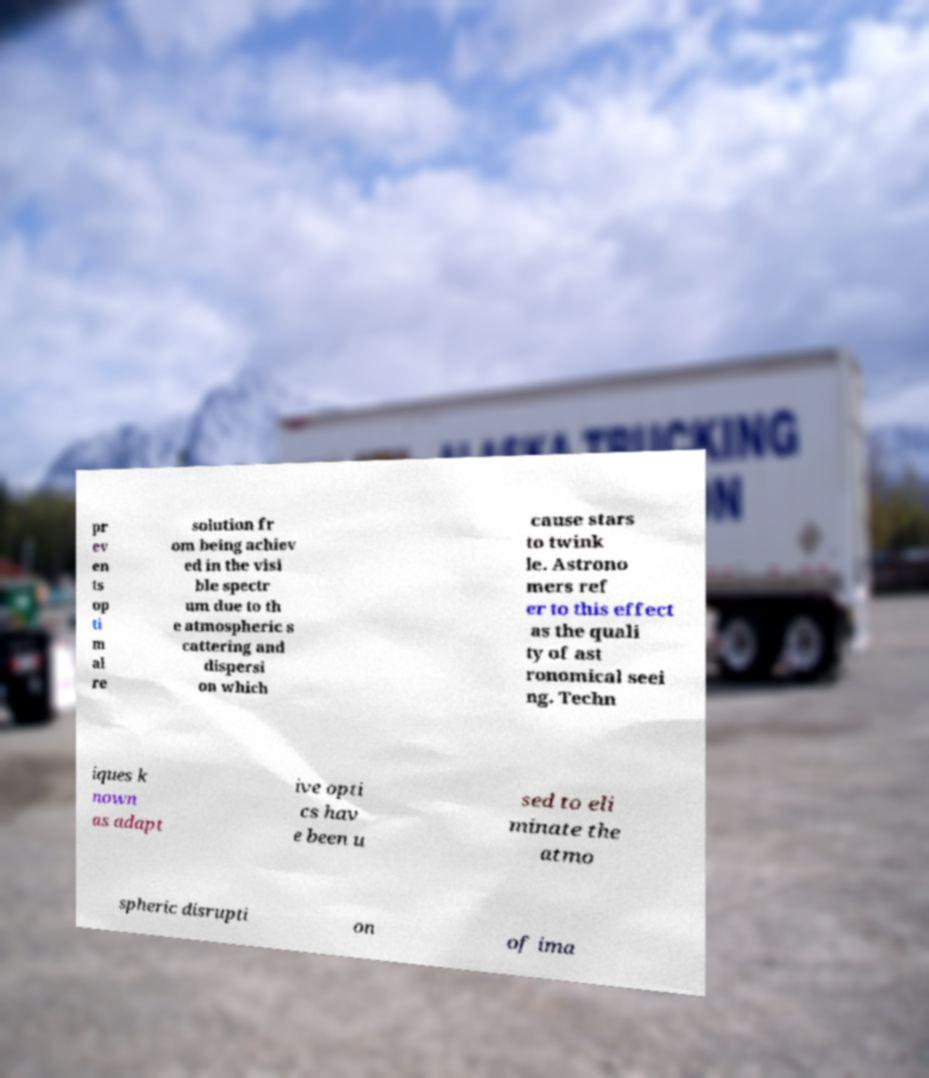Please identify and transcribe the text found in this image. pr ev en ts op ti m al re solution fr om being achiev ed in the visi ble spectr um due to th e atmospheric s cattering and dispersi on which cause stars to twink le. Astrono mers ref er to this effect as the quali ty of ast ronomical seei ng. Techn iques k nown as adapt ive opti cs hav e been u sed to eli minate the atmo spheric disrupti on of ima 